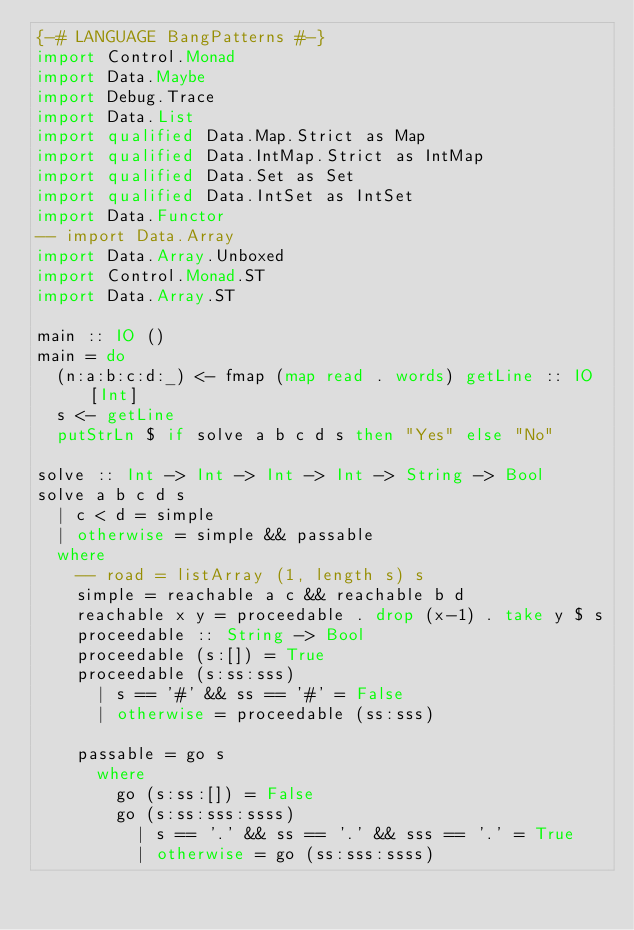Convert code to text. <code><loc_0><loc_0><loc_500><loc_500><_Haskell_>{-# LANGUAGE BangPatterns #-}
import Control.Monad
import Data.Maybe
import Debug.Trace
import Data.List
import qualified Data.Map.Strict as Map
import qualified Data.IntMap.Strict as IntMap
import qualified Data.Set as Set
import qualified Data.IntSet as IntSet
import Data.Functor
-- import Data.Array
import Data.Array.Unboxed
import Control.Monad.ST
import Data.Array.ST

main :: IO ()
main = do
  (n:a:b:c:d:_) <- fmap (map read . words) getLine :: IO [Int]
  s <- getLine
  putStrLn $ if solve a b c d s then "Yes" else "No"

solve :: Int -> Int -> Int -> Int -> String -> Bool
solve a b c d s 
  | c < d = simple
  | otherwise = simple && passable
  where
    -- road = listArray (1, length s) s
    simple = reachable a c && reachable b d
    reachable x y = proceedable . drop (x-1) . take y $ s
    proceedable :: String -> Bool
    proceedable (s:[]) = True
    proceedable (s:ss:sss)
      | s == '#' && ss == '#' = False
      | otherwise = proceedable (ss:sss)

    passable = go s
      where
        go (s:ss:[]) = False
        go (s:ss:sss:ssss)
          | s == '.' && ss == '.' && sss == '.' = True
          | otherwise = go (ss:sss:ssss)

</code> 